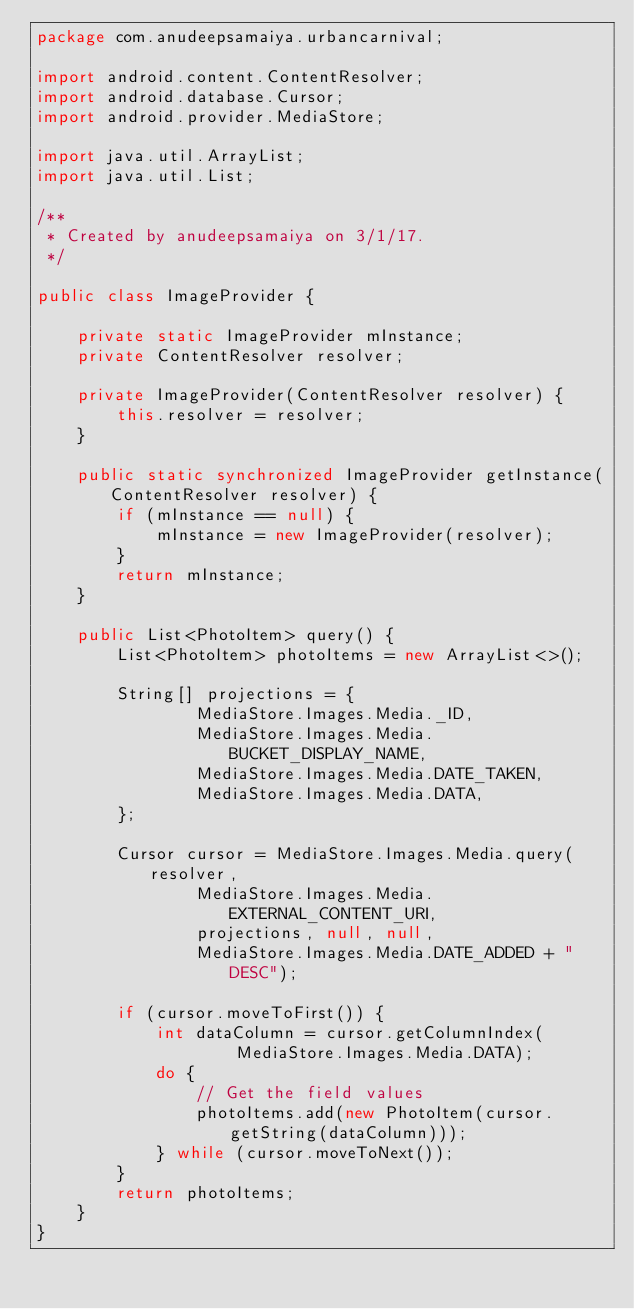<code> <loc_0><loc_0><loc_500><loc_500><_Java_>package com.anudeepsamaiya.urbancarnival;

import android.content.ContentResolver;
import android.database.Cursor;
import android.provider.MediaStore;

import java.util.ArrayList;
import java.util.List;

/**
 * Created by anudeepsamaiya on 3/1/17.
 */

public class ImageProvider {

    private static ImageProvider mInstance;
    private ContentResolver resolver;

    private ImageProvider(ContentResolver resolver) {
        this.resolver = resolver;
    }

    public static synchronized ImageProvider getInstance(ContentResolver resolver) {
        if (mInstance == null) {
            mInstance = new ImageProvider(resolver);
        }
        return mInstance;
    }

    public List<PhotoItem> query() {
        List<PhotoItem> photoItems = new ArrayList<>();

        String[] projections = {
                MediaStore.Images.Media._ID,
                MediaStore.Images.Media.BUCKET_DISPLAY_NAME,
                MediaStore.Images.Media.DATE_TAKEN,
                MediaStore.Images.Media.DATA,
        };

        Cursor cursor = MediaStore.Images.Media.query(resolver,
                MediaStore.Images.Media.EXTERNAL_CONTENT_URI,
                projections, null, null,
                MediaStore.Images.Media.DATE_ADDED + " DESC");

        if (cursor.moveToFirst()) {
            int dataColumn = cursor.getColumnIndex(
                    MediaStore.Images.Media.DATA);
            do {
                // Get the field values
                photoItems.add(new PhotoItem(cursor.getString(dataColumn)));
            } while (cursor.moveToNext());
        }
        return photoItems;
    }
}
</code> 